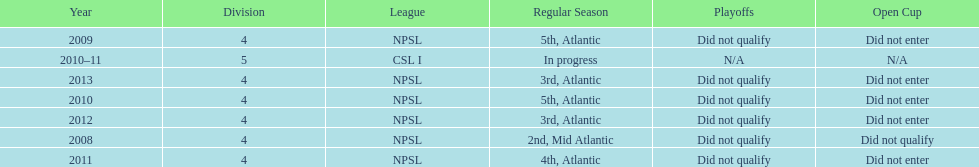What are all of the leagues? NPSL, NPSL, NPSL, CSL I, NPSL, NPSL, NPSL. Which league was played in the least? CSL I. 